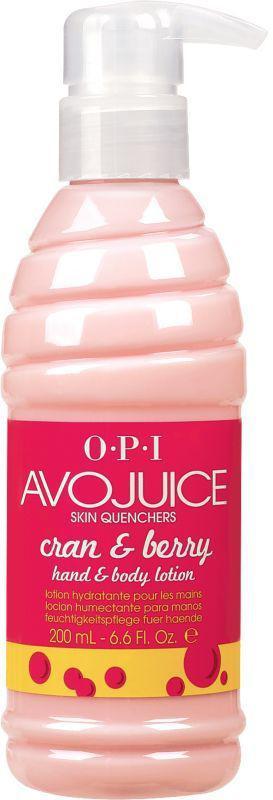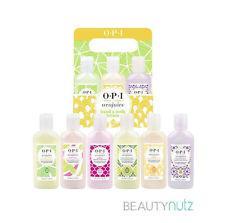The first image is the image on the left, the second image is the image on the right. Considering the images on both sides, is "At least four bottles of lotion are in one image, while the other image has just one pump bottle of lotion." valid? Answer yes or no. Yes. The first image is the image on the left, the second image is the image on the right. Examine the images to the left and right. Is the description "The left image features a single pump-top product." accurate? Answer yes or no. Yes. 